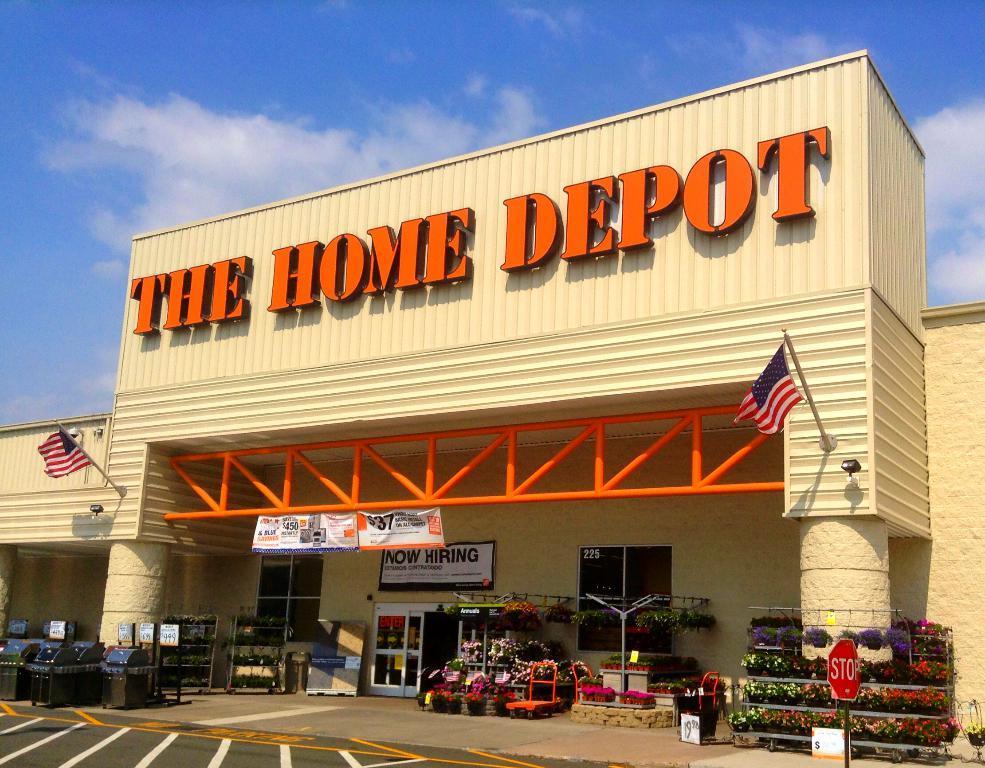Describe this image in one or two sentences. In this image we can see the building, there are dustbins, there are flower bouquets on the pavements, there are some houseplants, and bouquets on the racks, there are flags, lights, there is a signboard, there is a poster with text on it, there are boards with text on them, also we can see the sky. 